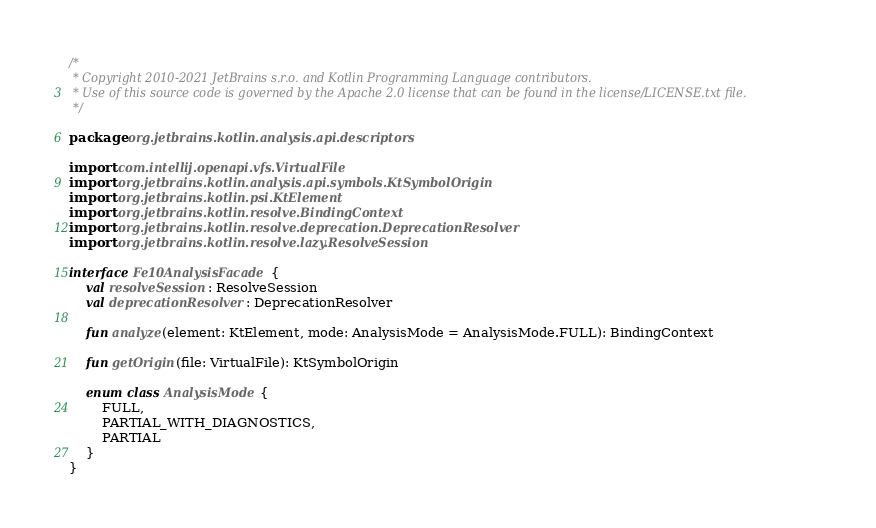Convert code to text. <code><loc_0><loc_0><loc_500><loc_500><_Kotlin_>/*
 * Copyright 2010-2021 JetBrains s.r.o. and Kotlin Programming Language contributors.
 * Use of this source code is governed by the Apache 2.0 license that can be found in the license/LICENSE.txt file.
 */

package org.jetbrains.kotlin.analysis.api.descriptors

import com.intellij.openapi.vfs.VirtualFile
import org.jetbrains.kotlin.analysis.api.symbols.KtSymbolOrigin
import org.jetbrains.kotlin.psi.KtElement
import org.jetbrains.kotlin.resolve.BindingContext
import org.jetbrains.kotlin.resolve.deprecation.DeprecationResolver
import org.jetbrains.kotlin.resolve.lazy.ResolveSession

interface Fe10AnalysisFacade {
    val resolveSession: ResolveSession
    val deprecationResolver: DeprecationResolver

    fun analyze(element: KtElement, mode: AnalysisMode = AnalysisMode.FULL): BindingContext

    fun getOrigin(file: VirtualFile): KtSymbolOrigin

    enum class AnalysisMode {
        FULL,
        PARTIAL_WITH_DIAGNOSTICS,
        PARTIAL
    }
}</code> 